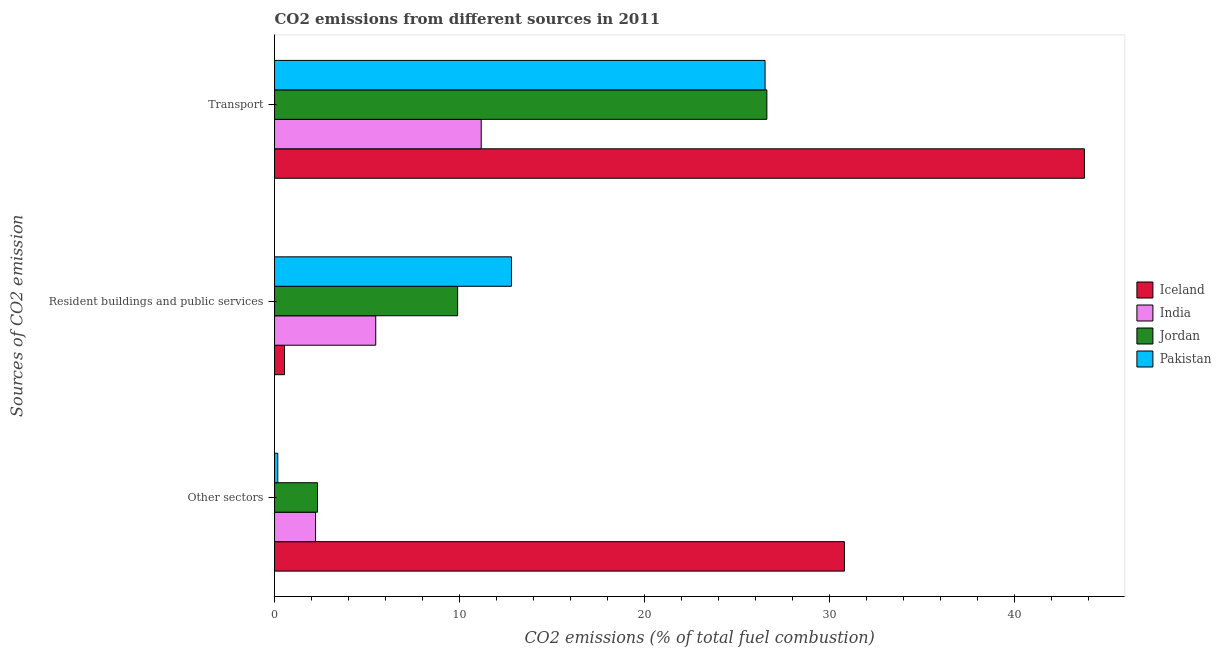How many different coloured bars are there?
Keep it short and to the point. 4. Are the number of bars on each tick of the Y-axis equal?
Make the answer very short. Yes. How many bars are there on the 3rd tick from the bottom?
Ensure brevity in your answer.  4. What is the label of the 2nd group of bars from the top?
Give a very brief answer. Resident buildings and public services. What is the percentage of co2 emissions from transport in Iceland?
Offer a terse response. 43.78. Across all countries, what is the maximum percentage of co2 emissions from transport?
Your answer should be very brief. 43.78. Across all countries, what is the minimum percentage of co2 emissions from resident buildings and public services?
Provide a short and direct response. 0.54. In which country was the percentage of co2 emissions from transport maximum?
Provide a short and direct response. Iceland. In which country was the percentage of co2 emissions from transport minimum?
Keep it short and to the point. India. What is the total percentage of co2 emissions from transport in the graph?
Provide a short and direct response. 108.09. What is the difference between the percentage of co2 emissions from transport in Pakistan and that in Jordan?
Your answer should be compact. -0.1. What is the difference between the percentage of co2 emissions from other sectors in India and the percentage of co2 emissions from transport in Iceland?
Your answer should be compact. -41.57. What is the average percentage of co2 emissions from other sectors per country?
Keep it short and to the point. 8.88. What is the difference between the percentage of co2 emissions from other sectors and percentage of co2 emissions from transport in Pakistan?
Offer a very short reply. -26.34. What is the ratio of the percentage of co2 emissions from transport in Iceland to that in India?
Make the answer very short. 3.92. What is the difference between the highest and the second highest percentage of co2 emissions from resident buildings and public services?
Your response must be concise. 2.91. What is the difference between the highest and the lowest percentage of co2 emissions from other sectors?
Ensure brevity in your answer.  30.63. In how many countries, is the percentage of co2 emissions from transport greater than the average percentage of co2 emissions from transport taken over all countries?
Your answer should be compact. 1. Is the sum of the percentage of co2 emissions from transport in Jordan and Pakistan greater than the maximum percentage of co2 emissions from other sectors across all countries?
Your response must be concise. Yes. Is it the case that in every country, the sum of the percentage of co2 emissions from other sectors and percentage of co2 emissions from resident buildings and public services is greater than the percentage of co2 emissions from transport?
Give a very brief answer. No. Are all the bars in the graph horizontal?
Make the answer very short. Yes. How many countries are there in the graph?
Keep it short and to the point. 4. What is the difference between two consecutive major ticks on the X-axis?
Offer a very short reply. 10. Are the values on the major ticks of X-axis written in scientific E-notation?
Ensure brevity in your answer.  No. Does the graph contain any zero values?
Make the answer very short. No. Does the graph contain grids?
Your answer should be very brief. No. What is the title of the graph?
Make the answer very short. CO2 emissions from different sources in 2011. Does "Tonga" appear as one of the legend labels in the graph?
Your answer should be compact. No. What is the label or title of the X-axis?
Make the answer very short. CO2 emissions (% of total fuel combustion). What is the label or title of the Y-axis?
Keep it short and to the point. Sources of CO2 emission. What is the CO2 emissions (% of total fuel combustion) in Iceland in Other sectors?
Offer a terse response. 30.81. What is the CO2 emissions (% of total fuel combustion) of India in Other sectors?
Offer a terse response. 2.22. What is the CO2 emissions (% of total fuel combustion) of Jordan in Other sectors?
Offer a terse response. 2.32. What is the CO2 emissions (% of total fuel combustion) in Pakistan in Other sectors?
Give a very brief answer. 0.18. What is the CO2 emissions (% of total fuel combustion) in Iceland in Resident buildings and public services?
Keep it short and to the point. 0.54. What is the CO2 emissions (% of total fuel combustion) in India in Resident buildings and public services?
Ensure brevity in your answer.  5.47. What is the CO2 emissions (% of total fuel combustion) of Jordan in Resident buildings and public services?
Ensure brevity in your answer.  9.9. What is the CO2 emissions (% of total fuel combustion) in Pakistan in Resident buildings and public services?
Offer a terse response. 12.81. What is the CO2 emissions (% of total fuel combustion) of Iceland in Transport?
Keep it short and to the point. 43.78. What is the CO2 emissions (% of total fuel combustion) in India in Transport?
Offer a very short reply. 11.17. What is the CO2 emissions (% of total fuel combustion) in Jordan in Transport?
Your answer should be compact. 26.62. What is the CO2 emissions (% of total fuel combustion) of Pakistan in Transport?
Ensure brevity in your answer.  26.52. Across all Sources of CO2 emission, what is the maximum CO2 emissions (% of total fuel combustion) of Iceland?
Keep it short and to the point. 43.78. Across all Sources of CO2 emission, what is the maximum CO2 emissions (% of total fuel combustion) of India?
Make the answer very short. 11.17. Across all Sources of CO2 emission, what is the maximum CO2 emissions (% of total fuel combustion) in Jordan?
Keep it short and to the point. 26.62. Across all Sources of CO2 emission, what is the maximum CO2 emissions (% of total fuel combustion) of Pakistan?
Keep it short and to the point. 26.52. Across all Sources of CO2 emission, what is the minimum CO2 emissions (% of total fuel combustion) in Iceland?
Make the answer very short. 0.54. Across all Sources of CO2 emission, what is the minimum CO2 emissions (% of total fuel combustion) of India?
Provide a short and direct response. 2.22. Across all Sources of CO2 emission, what is the minimum CO2 emissions (% of total fuel combustion) of Jordan?
Your answer should be compact. 2.32. Across all Sources of CO2 emission, what is the minimum CO2 emissions (% of total fuel combustion) of Pakistan?
Your response must be concise. 0.18. What is the total CO2 emissions (% of total fuel combustion) in Iceland in the graph?
Your answer should be very brief. 75.14. What is the total CO2 emissions (% of total fuel combustion) in India in the graph?
Offer a terse response. 18.86. What is the total CO2 emissions (% of total fuel combustion) in Jordan in the graph?
Offer a terse response. 38.84. What is the total CO2 emissions (% of total fuel combustion) of Pakistan in the graph?
Your answer should be compact. 39.5. What is the difference between the CO2 emissions (% of total fuel combustion) in Iceland in Other sectors and that in Resident buildings and public services?
Give a very brief answer. 30.27. What is the difference between the CO2 emissions (% of total fuel combustion) of India in Other sectors and that in Resident buildings and public services?
Make the answer very short. -3.25. What is the difference between the CO2 emissions (% of total fuel combustion) in Jordan in Other sectors and that in Resident buildings and public services?
Ensure brevity in your answer.  -7.58. What is the difference between the CO2 emissions (% of total fuel combustion) in Pakistan in Other sectors and that in Resident buildings and public services?
Ensure brevity in your answer.  -12.63. What is the difference between the CO2 emissions (% of total fuel combustion) of Iceland in Other sectors and that in Transport?
Keep it short and to the point. -12.97. What is the difference between the CO2 emissions (% of total fuel combustion) of India in Other sectors and that in Transport?
Offer a terse response. -8.96. What is the difference between the CO2 emissions (% of total fuel combustion) in Jordan in Other sectors and that in Transport?
Your response must be concise. -24.29. What is the difference between the CO2 emissions (% of total fuel combustion) of Pakistan in Other sectors and that in Transport?
Offer a very short reply. -26.34. What is the difference between the CO2 emissions (% of total fuel combustion) in Iceland in Resident buildings and public services and that in Transport?
Offer a terse response. -43.24. What is the difference between the CO2 emissions (% of total fuel combustion) in India in Resident buildings and public services and that in Transport?
Keep it short and to the point. -5.7. What is the difference between the CO2 emissions (% of total fuel combustion) of Jordan in Resident buildings and public services and that in Transport?
Offer a terse response. -16.72. What is the difference between the CO2 emissions (% of total fuel combustion) of Pakistan in Resident buildings and public services and that in Transport?
Offer a terse response. -13.71. What is the difference between the CO2 emissions (% of total fuel combustion) of Iceland in Other sectors and the CO2 emissions (% of total fuel combustion) of India in Resident buildings and public services?
Your answer should be very brief. 25.34. What is the difference between the CO2 emissions (% of total fuel combustion) of Iceland in Other sectors and the CO2 emissions (% of total fuel combustion) of Jordan in Resident buildings and public services?
Ensure brevity in your answer.  20.91. What is the difference between the CO2 emissions (% of total fuel combustion) of Iceland in Other sectors and the CO2 emissions (% of total fuel combustion) of Pakistan in Resident buildings and public services?
Your answer should be very brief. 18. What is the difference between the CO2 emissions (% of total fuel combustion) in India in Other sectors and the CO2 emissions (% of total fuel combustion) in Jordan in Resident buildings and public services?
Give a very brief answer. -7.68. What is the difference between the CO2 emissions (% of total fuel combustion) in India in Other sectors and the CO2 emissions (% of total fuel combustion) in Pakistan in Resident buildings and public services?
Ensure brevity in your answer.  -10.59. What is the difference between the CO2 emissions (% of total fuel combustion) of Jordan in Other sectors and the CO2 emissions (% of total fuel combustion) of Pakistan in Resident buildings and public services?
Offer a terse response. -10.49. What is the difference between the CO2 emissions (% of total fuel combustion) in Iceland in Other sectors and the CO2 emissions (% of total fuel combustion) in India in Transport?
Provide a succinct answer. 19.64. What is the difference between the CO2 emissions (% of total fuel combustion) of Iceland in Other sectors and the CO2 emissions (% of total fuel combustion) of Jordan in Transport?
Your response must be concise. 4.19. What is the difference between the CO2 emissions (% of total fuel combustion) of Iceland in Other sectors and the CO2 emissions (% of total fuel combustion) of Pakistan in Transport?
Keep it short and to the point. 4.29. What is the difference between the CO2 emissions (% of total fuel combustion) of India in Other sectors and the CO2 emissions (% of total fuel combustion) of Jordan in Transport?
Give a very brief answer. -24.4. What is the difference between the CO2 emissions (% of total fuel combustion) in India in Other sectors and the CO2 emissions (% of total fuel combustion) in Pakistan in Transport?
Make the answer very short. -24.3. What is the difference between the CO2 emissions (% of total fuel combustion) of Jordan in Other sectors and the CO2 emissions (% of total fuel combustion) of Pakistan in Transport?
Give a very brief answer. -24.2. What is the difference between the CO2 emissions (% of total fuel combustion) in Iceland in Resident buildings and public services and the CO2 emissions (% of total fuel combustion) in India in Transport?
Your answer should be very brief. -10.63. What is the difference between the CO2 emissions (% of total fuel combustion) in Iceland in Resident buildings and public services and the CO2 emissions (% of total fuel combustion) in Jordan in Transport?
Offer a very short reply. -26.08. What is the difference between the CO2 emissions (% of total fuel combustion) of Iceland in Resident buildings and public services and the CO2 emissions (% of total fuel combustion) of Pakistan in Transport?
Provide a short and direct response. -25.98. What is the difference between the CO2 emissions (% of total fuel combustion) in India in Resident buildings and public services and the CO2 emissions (% of total fuel combustion) in Jordan in Transport?
Keep it short and to the point. -21.15. What is the difference between the CO2 emissions (% of total fuel combustion) of India in Resident buildings and public services and the CO2 emissions (% of total fuel combustion) of Pakistan in Transport?
Your answer should be very brief. -21.05. What is the difference between the CO2 emissions (% of total fuel combustion) of Jordan in Resident buildings and public services and the CO2 emissions (% of total fuel combustion) of Pakistan in Transport?
Offer a very short reply. -16.62. What is the average CO2 emissions (% of total fuel combustion) of Iceland per Sources of CO2 emission?
Give a very brief answer. 25.05. What is the average CO2 emissions (% of total fuel combustion) in India per Sources of CO2 emission?
Offer a very short reply. 6.29. What is the average CO2 emissions (% of total fuel combustion) in Jordan per Sources of CO2 emission?
Provide a short and direct response. 12.95. What is the average CO2 emissions (% of total fuel combustion) of Pakistan per Sources of CO2 emission?
Keep it short and to the point. 13.17. What is the difference between the CO2 emissions (% of total fuel combustion) of Iceland and CO2 emissions (% of total fuel combustion) of India in Other sectors?
Give a very brief answer. 28.59. What is the difference between the CO2 emissions (% of total fuel combustion) of Iceland and CO2 emissions (% of total fuel combustion) of Jordan in Other sectors?
Ensure brevity in your answer.  28.49. What is the difference between the CO2 emissions (% of total fuel combustion) in Iceland and CO2 emissions (% of total fuel combustion) in Pakistan in Other sectors?
Your response must be concise. 30.63. What is the difference between the CO2 emissions (% of total fuel combustion) of India and CO2 emissions (% of total fuel combustion) of Jordan in Other sectors?
Your answer should be very brief. -0.11. What is the difference between the CO2 emissions (% of total fuel combustion) of India and CO2 emissions (% of total fuel combustion) of Pakistan in Other sectors?
Offer a terse response. 2.04. What is the difference between the CO2 emissions (% of total fuel combustion) of Jordan and CO2 emissions (% of total fuel combustion) of Pakistan in Other sectors?
Give a very brief answer. 2.15. What is the difference between the CO2 emissions (% of total fuel combustion) of Iceland and CO2 emissions (% of total fuel combustion) of India in Resident buildings and public services?
Ensure brevity in your answer.  -4.93. What is the difference between the CO2 emissions (% of total fuel combustion) of Iceland and CO2 emissions (% of total fuel combustion) of Jordan in Resident buildings and public services?
Your response must be concise. -9.36. What is the difference between the CO2 emissions (% of total fuel combustion) of Iceland and CO2 emissions (% of total fuel combustion) of Pakistan in Resident buildings and public services?
Make the answer very short. -12.27. What is the difference between the CO2 emissions (% of total fuel combustion) in India and CO2 emissions (% of total fuel combustion) in Jordan in Resident buildings and public services?
Ensure brevity in your answer.  -4.43. What is the difference between the CO2 emissions (% of total fuel combustion) of India and CO2 emissions (% of total fuel combustion) of Pakistan in Resident buildings and public services?
Make the answer very short. -7.34. What is the difference between the CO2 emissions (% of total fuel combustion) in Jordan and CO2 emissions (% of total fuel combustion) in Pakistan in Resident buildings and public services?
Offer a terse response. -2.91. What is the difference between the CO2 emissions (% of total fuel combustion) of Iceland and CO2 emissions (% of total fuel combustion) of India in Transport?
Make the answer very short. 32.61. What is the difference between the CO2 emissions (% of total fuel combustion) in Iceland and CO2 emissions (% of total fuel combustion) in Jordan in Transport?
Your response must be concise. 17.17. What is the difference between the CO2 emissions (% of total fuel combustion) in Iceland and CO2 emissions (% of total fuel combustion) in Pakistan in Transport?
Give a very brief answer. 17.26. What is the difference between the CO2 emissions (% of total fuel combustion) of India and CO2 emissions (% of total fuel combustion) of Jordan in Transport?
Offer a terse response. -15.44. What is the difference between the CO2 emissions (% of total fuel combustion) of India and CO2 emissions (% of total fuel combustion) of Pakistan in Transport?
Provide a succinct answer. -15.35. What is the difference between the CO2 emissions (% of total fuel combustion) of Jordan and CO2 emissions (% of total fuel combustion) of Pakistan in Transport?
Keep it short and to the point. 0.1. What is the ratio of the CO2 emissions (% of total fuel combustion) in India in Other sectors to that in Resident buildings and public services?
Provide a short and direct response. 0.41. What is the ratio of the CO2 emissions (% of total fuel combustion) in Jordan in Other sectors to that in Resident buildings and public services?
Give a very brief answer. 0.23. What is the ratio of the CO2 emissions (% of total fuel combustion) of Pakistan in Other sectors to that in Resident buildings and public services?
Your answer should be very brief. 0.01. What is the ratio of the CO2 emissions (% of total fuel combustion) in Iceland in Other sectors to that in Transport?
Give a very brief answer. 0.7. What is the ratio of the CO2 emissions (% of total fuel combustion) of India in Other sectors to that in Transport?
Your response must be concise. 0.2. What is the ratio of the CO2 emissions (% of total fuel combustion) in Jordan in Other sectors to that in Transport?
Make the answer very short. 0.09. What is the ratio of the CO2 emissions (% of total fuel combustion) of Pakistan in Other sectors to that in Transport?
Your answer should be compact. 0.01. What is the ratio of the CO2 emissions (% of total fuel combustion) in Iceland in Resident buildings and public services to that in Transport?
Your answer should be very brief. 0.01. What is the ratio of the CO2 emissions (% of total fuel combustion) of India in Resident buildings and public services to that in Transport?
Offer a very short reply. 0.49. What is the ratio of the CO2 emissions (% of total fuel combustion) of Jordan in Resident buildings and public services to that in Transport?
Ensure brevity in your answer.  0.37. What is the ratio of the CO2 emissions (% of total fuel combustion) of Pakistan in Resident buildings and public services to that in Transport?
Offer a very short reply. 0.48. What is the difference between the highest and the second highest CO2 emissions (% of total fuel combustion) in Iceland?
Offer a very short reply. 12.97. What is the difference between the highest and the second highest CO2 emissions (% of total fuel combustion) of India?
Ensure brevity in your answer.  5.7. What is the difference between the highest and the second highest CO2 emissions (% of total fuel combustion) of Jordan?
Give a very brief answer. 16.72. What is the difference between the highest and the second highest CO2 emissions (% of total fuel combustion) in Pakistan?
Offer a very short reply. 13.71. What is the difference between the highest and the lowest CO2 emissions (% of total fuel combustion) in Iceland?
Give a very brief answer. 43.24. What is the difference between the highest and the lowest CO2 emissions (% of total fuel combustion) of India?
Offer a terse response. 8.96. What is the difference between the highest and the lowest CO2 emissions (% of total fuel combustion) in Jordan?
Your response must be concise. 24.29. What is the difference between the highest and the lowest CO2 emissions (% of total fuel combustion) in Pakistan?
Your response must be concise. 26.34. 